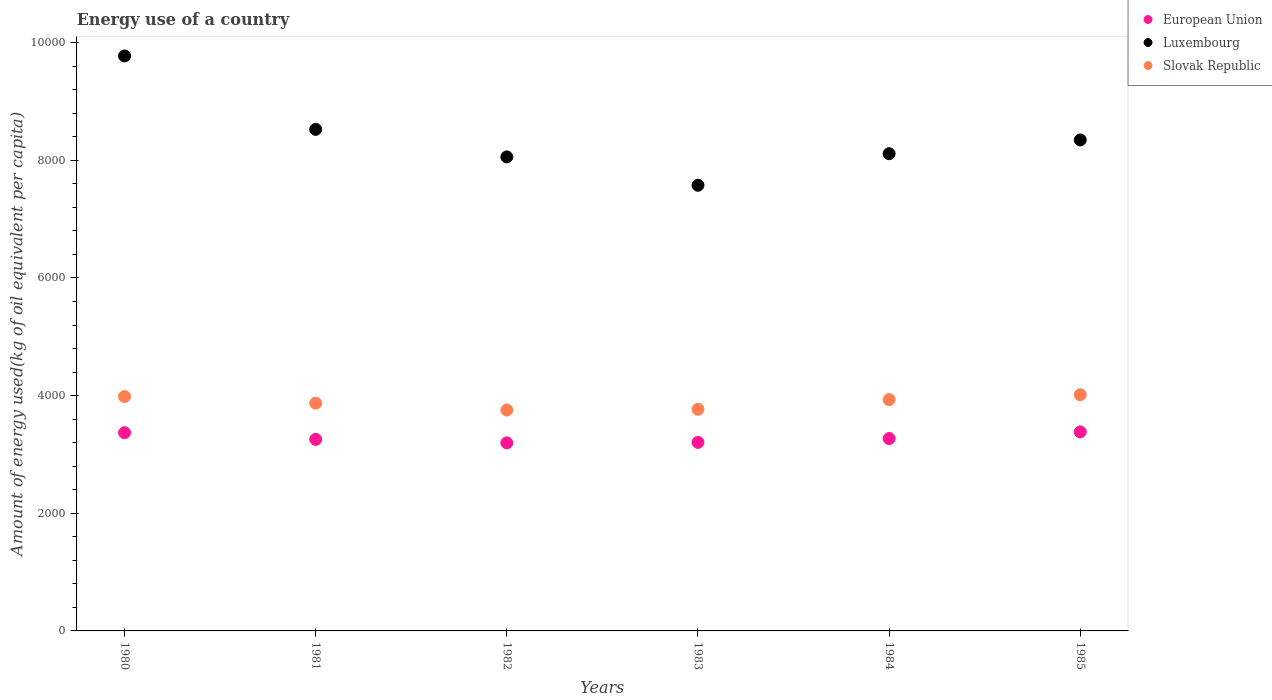How many different coloured dotlines are there?
Give a very brief answer. 3. What is the amount of energy used in in Luxembourg in 1982?
Provide a short and direct response. 8057.81. Across all years, what is the maximum amount of energy used in in European Union?
Your response must be concise. 3383.17. Across all years, what is the minimum amount of energy used in in European Union?
Your answer should be compact. 3196.65. In which year was the amount of energy used in in Luxembourg minimum?
Give a very brief answer. 1983. What is the total amount of energy used in in European Union in the graph?
Provide a succinct answer. 1.97e+04. What is the difference between the amount of energy used in in Luxembourg in 1981 and that in 1982?
Provide a succinct answer. 468.23. What is the difference between the amount of energy used in in European Union in 1980 and the amount of energy used in in Luxembourg in 1982?
Ensure brevity in your answer.  -4688.42. What is the average amount of energy used in in European Union per year?
Your answer should be very brief. 3280.22. In the year 1983, what is the difference between the amount of energy used in in Slovak Republic and amount of energy used in in European Union?
Make the answer very short. 562.69. In how many years, is the amount of energy used in in European Union greater than 8400 kg?
Your answer should be compact. 0. What is the ratio of the amount of energy used in in Slovak Republic in 1980 to that in 1982?
Keep it short and to the point. 1.06. Is the amount of energy used in in European Union in 1981 less than that in 1984?
Offer a terse response. Yes. Is the difference between the amount of energy used in in Slovak Republic in 1980 and 1981 greater than the difference between the amount of energy used in in European Union in 1980 and 1981?
Ensure brevity in your answer.  No. What is the difference between the highest and the second highest amount of energy used in in Slovak Republic?
Keep it short and to the point. 31.31. What is the difference between the highest and the lowest amount of energy used in in Luxembourg?
Ensure brevity in your answer.  2198.44. In how many years, is the amount of energy used in in Luxembourg greater than the average amount of energy used in in Luxembourg taken over all years?
Your answer should be compact. 2. Is the amount of energy used in in Luxembourg strictly less than the amount of energy used in in European Union over the years?
Give a very brief answer. No. How many dotlines are there?
Ensure brevity in your answer.  3. What is the difference between two consecutive major ticks on the Y-axis?
Ensure brevity in your answer.  2000. Does the graph contain any zero values?
Your response must be concise. No. Where does the legend appear in the graph?
Your answer should be compact. Top right. What is the title of the graph?
Provide a short and direct response. Energy use of a country. What is the label or title of the X-axis?
Offer a terse response. Years. What is the label or title of the Y-axis?
Your answer should be very brief. Amount of energy used(kg of oil equivalent per capita). What is the Amount of energy used(kg of oil equivalent per capita) of European Union in 1980?
Offer a terse response. 3369.39. What is the Amount of energy used(kg of oil equivalent per capita) in Luxembourg in 1980?
Keep it short and to the point. 9774.65. What is the Amount of energy used(kg of oil equivalent per capita) in Slovak Republic in 1980?
Provide a short and direct response. 3983.84. What is the Amount of energy used(kg of oil equivalent per capita) in European Union in 1981?
Your answer should be very brief. 3256.81. What is the Amount of energy used(kg of oil equivalent per capita) of Luxembourg in 1981?
Provide a succinct answer. 8526.04. What is the Amount of energy used(kg of oil equivalent per capita) of Slovak Republic in 1981?
Give a very brief answer. 3872.54. What is the Amount of energy used(kg of oil equivalent per capita) in European Union in 1982?
Offer a very short reply. 3196.65. What is the Amount of energy used(kg of oil equivalent per capita) in Luxembourg in 1982?
Your answer should be compact. 8057.81. What is the Amount of energy used(kg of oil equivalent per capita) of Slovak Republic in 1982?
Offer a very short reply. 3754.68. What is the Amount of energy used(kg of oil equivalent per capita) of European Union in 1983?
Ensure brevity in your answer.  3204.9. What is the Amount of energy used(kg of oil equivalent per capita) in Luxembourg in 1983?
Ensure brevity in your answer.  7576.21. What is the Amount of energy used(kg of oil equivalent per capita) of Slovak Republic in 1983?
Your response must be concise. 3767.6. What is the Amount of energy used(kg of oil equivalent per capita) in European Union in 1984?
Your answer should be very brief. 3270.42. What is the Amount of energy used(kg of oil equivalent per capita) in Luxembourg in 1984?
Give a very brief answer. 8112.68. What is the Amount of energy used(kg of oil equivalent per capita) of Slovak Republic in 1984?
Ensure brevity in your answer.  3932.19. What is the Amount of energy used(kg of oil equivalent per capita) of European Union in 1985?
Provide a short and direct response. 3383.17. What is the Amount of energy used(kg of oil equivalent per capita) in Luxembourg in 1985?
Give a very brief answer. 8346.93. What is the Amount of energy used(kg of oil equivalent per capita) in Slovak Republic in 1985?
Provide a succinct answer. 4015.15. Across all years, what is the maximum Amount of energy used(kg of oil equivalent per capita) of European Union?
Provide a succinct answer. 3383.17. Across all years, what is the maximum Amount of energy used(kg of oil equivalent per capita) in Luxembourg?
Ensure brevity in your answer.  9774.65. Across all years, what is the maximum Amount of energy used(kg of oil equivalent per capita) in Slovak Republic?
Offer a very short reply. 4015.15. Across all years, what is the minimum Amount of energy used(kg of oil equivalent per capita) of European Union?
Keep it short and to the point. 3196.65. Across all years, what is the minimum Amount of energy used(kg of oil equivalent per capita) of Luxembourg?
Provide a short and direct response. 7576.21. Across all years, what is the minimum Amount of energy used(kg of oil equivalent per capita) of Slovak Republic?
Offer a terse response. 3754.68. What is the total Amount of energy used(kg of oil equivalent per capita) of European Union in the graph?
Your answer should be compact. 1.97e+04. What is the total Amount of energy used(kg of oil equivalent per capita) of Luxembourg in the graph?
Your response must be concise. 5.04e+04. What is the total Amount of energy used(kg of oil equivalent per capita) in Slovak Republic in the graph?
Your answer should be very brief. 2.33e+04. What is the difference between the Amount of energy used(kg of oil equivalent per capita) of European Union in 1980 and that in 1981?
Keep it short and to the point. 112.58. What is the difference between the Amount of energy used(kg of oil equivalent per capita) in Luxembourg in 1980 and that in 1981?
Your answer should be compact. 1248.61. What is the difference between the Amount of energy used(kg of oil equivalent per capita) of Slovak Republic in 1980 and that in 1981?
Provide a short and direct response. 111.31. What is the difference between the Amount of energy used(kg of oil equivalent per capita) of European Union in 1980 and that in 1982?
Your answer should be compact. 172.74. What is the difference between the Amount of energy used(kg of oil equivalent per capita) of Luxembourg in 1980 and that in 1982?
Your answer should be very brief. 1716.84. What is the difference between the Amount of energy used(kg of oil equivalent per capita) of Slovak Republic in 1980 and that in 1982?
Make the answer very short. 229.16. What is the difference between the Amount of energy used(kg of oil equivalent per capita) of European Union in 1980 and that in 1983?
Give a very brief answer. 164.49. What is the difference between the Amount of energy used(kg of oil equivalent per capita) of Luxembourg in 1980 and that in 1983?
Offer a terse response. 2198.44. What is the difference between the Amount of energy used(kg of oil equivalent per capita) in Slovak Republic in 1980 and that in 1983?
Keep it short and to the point. 216.25. What is the difference between the Amount of energy used(kg of oil equivalent per capita) in European Union in 1980 and that in 1984?
Ensure brevity in your answer.  98.97. What is the difference between the Amount of energy used(kg of oil equivalent per capita) in Luxembourg in 1980 and that in 1984?
Offer a very short reply. 1661.98. What is the difference between the Amount of energy used(kg of oil equivalent per capita) in Slovak Republic in 1980 and that in 1984?
Make the answer very short. 51.65. What is the difference between the Amount of energy used(kg of oil equivalent per capita) of European Union in 1980 and that in 1985?
Make the answer very short. -13.78. What is the difference between the Amount of energy used(kg of oil equivalent per capita) in Luxembourg in 1980 and that in 1985?
Give a very brief answer. 1427.72. What is the difference between the Amount of energy used(kg of oil equivalent per capita) of Slovak Republic in 1980 and that in 1985?
Your answer should be very brief. -31.31. What is the difference between the Amount of energy used(kg of oil equivalent per capita) of European Union in 1981 and that in 1982?
Offer a very short reply. 60.16. What is the difference between the Amount of energy used(kg of oil equivalent per capita) of Luxembourg in 1981 and that in 1982?
Give a very brief answer. 468.23. What is the difference between the Amount of energy used(kg of oil equivalent per capita) in Slovak Republic in 1981 and that in 1982?
Your answer should be compact. 117.86. What is the difference between the Amount of energy used(kg of oil equivalent per capita) of European Union in 1981 and that in 1983?
Ensure brevity in your answer.  51.91. What is the difference between the Amount of energy used(kg of oil equivalent per capita) of Luxembourg in 1981 and that in 1983?
Your answer should be very brief. 949.83. What is the difference between the Amount of energy used(kg of oil equivalent per capita) of Slovak Republic in 1981 and that in 1983?
Ensure brevity in your answer.  104.94. What is the difference between the Amount of energy used(kg of oil equivalent per capita) of European Union in 1981 and that in 1984?
Keep it short and to the point. -13.61. What is the difference between the Amount of energy used(kg of oil equivalent per capita) of Luxembourg in 1981 and that in 1984?
Your response must be concise. 413.36. What is the difference between the Amount of energy used(kg of oil equivalent per capita) of Slovak Republic in 1981 and that in 1984?
Ensure brevity in your answer.  -59.66. What is the difference between the Amount of energy used(kg of oil equivalent per capita) in European Union in 1981 and that in 1985?
Your answer should be very brief. -126.36. What is the difference between the Amount of energy used(kg of oil equivalent per capita) in Luxembourg in 1981 and that in 1985?
Give a very brief answer. 179.11. What is the difference between the Amount of energy used(kg of oil equivalent per capita) in Slovak Republic in 1981 and that in 1985?
Make the answer very short. -142.62. What is the difference between the Amount of energy used(kg of oil equivalent per capita) of European Union in 1982 and that in 1983?
Your response must be concise. -8.25. What is the difference between the Amount of energy used(kg of oil equivalent per capita) in Luxembourg in 1982 and that in 1983?
Give a very brief answer. 481.6. What is the difference between the Amount of energy used(kg of oil equivalent per capita) in Slovak Republic in 1982 and that in 1983?
Your response must be concise. -12.92. What is the difference between the Amount of energy used(kg of oil equivalent per capita) in European Union in 1982 and that in 1984?
Keep it short and to the point. -73.77. What is the difference between the Amount of energy used(kg of oil equivalent per capita) in Luxembourg in 1982 and that in 1984?
Your answer should be compact. -54.87. What is the difference between the Amount of energy used(kg of oil equivalent per capita) in Slovak Republic in 1982 and that in 1984?
Your answer should be very brief. -177.51. What is the difference between the Amount of energy used(kg of oil equivalent per capita) of European Union in 1982 and that in 1985?
Provide a short and direct response. -186.52. What is the difference between the Amount of energy used(kg of oil equivalent per capita) in Luxembourg in 1982 and that in 1985?
Offer a terse response. -289.12. What is the difference between the Amount of energy used(kg of oil equivalent per capita) of Slovak Republic in 1982 and that in 1985?
Keep it short and to the point. -260.47. What is the difference between the Amount of energy used(kg of oil equivalent per capita) of European Union in 1983 and that in 1984?
Offer a very short reply. -65.52. What is the difference between the Amount of energy used(kg of oil equivalent per capita) in Luxembourg in 1983 and that in 1984?
Give a very brief answer. -536.47. What is the difference between the Amount of energy used(kg of oil equivalent per capita) of Slovak Republic in 1983 and that in 1984?
Provide a succinct answer. -164.6. What is the difference between the Amount of energy used(kg of oil equivalent per capita) of European Union in 1983 and that in 1985?
Your response must be concise. -178.27. What is the difference between the Amount of energy used(kg of oil equivalent per capita) in Luxembourg in 1983 and that in 1985?
Your response must be concise. -770.72. What is the difference between the Amount of energy used(kg of oil equivalent per capita) of Slovak Republic in 1983 and that in 1985?
Offer a very short reply. -247.56. What is the difference between the Amount of energy used(kg of oil equivalent per capita) in European Union in 1984 and that in 1985?
Your response must be concise. -112.75. What is the difference between the Amount of energy used(kg of oil equivalent per capita) in Luxembourg in 1984 and that in 1985?
Offer a terse response. -234.25. What is the difference between the Amount of energy used(kg of oil equivalent per capita) of Slovak Republic in 1984 and that in 1985?
Offer a terse response. -82.96. What is the difference between the Amount of energy used(kg of oil equivalent per capita) in European Union in 1980 and the Amount of energy used(kg of oil equivalent per capita) in Luxembourg in 1981?
Provide a short and direct response. -5156.65. What is the difference between the Amount of energy used(kg of oil equivalent per capita) of European Union in 1980 and the Amount of energy used(kg of oil equivalent per capita) of Slovak Republic in 1981?
Make the answer very short. -503.15. What is the difference between the Amount of energy used(kg of oil equivalent per capita) of Luxembourg in 1980 and the Amount of energy used(kg of oil equivalent per capita) of Slovak Republic in 1981?
Provide a short and direct response. 5902.11. What is the difference between the Amount of energy used(kg of oil equivalent per capita) in European Union in 1980 and the Amount of energy used(kg of oil equivalent per capita) in Luxembourg in 1982?
Offer a very short reply. -4688.42. What is the difference between the Amount of energy used(kg of oil equivalent per capita) of European Union in 1980 and the Amount of energy used(kg of oil equivalent per capita) of Slovak Republic in 1982?
Make the answer very short. -385.29. What is the difference between the Amount of energy used(kg of oil equivalent per capita) in Luxembourg in 1980 and the Amount of energy used(kg of oil equivalent per capita) in Slovak Republic in 1982?
Ensure brevity in your answer.  6019.97. What is the difference between the Amount of energy used(kg of oil equivalent per capita) in European Union in 1980 and the Amount of energy used(kg of oil equivalent per capita) in Luxembourg in 1983?
Provide a succinct answer. -4206.82. What is the difference between the Amount of energy used(kg of oil equivalent per capita) in European Union in 1980 and the Amount of energy used(kg of oil equivalent per capita) in Slovak Republic in 1983?
Ensure brevity in your answer.  -398.21. What is the difference between the Amount of energy used(kg of oil equivalent per capita) of Luxembourg in 1980 and the Amount of energy used(kg of oil equivalent per capita) of Slovak Republic in 1983?
Ensure brevity in your answer.  6007.05. What is the difference between the Amount of energy used(kg of oil equivalent per capita) of European Union in 1980 and the Amount of energy used(kg of oil equivalent per capita) of Luxembourg in 1984?
Keep it short and to the point. -4743.29. What is the difference between the Amount of energy used(kg of oil equivalent per capita) in European Union in 1980 and the Amount of energy used(kg of oil equivalent per capita) in Slovak Republic in 1984?
Provide a short and direct response. -562.8. What is the difference between the Amount of energy used(kg of oil equivalent per capita) in Luxembourg in 1980 and the Amount of energy used(kg of oil equivalent per capita) in Slovak Republic in 1984?
Offer a terse response. 5842.46. What is the difference between the Amount of energy used(kg of oil equivalent per capita) of European Union in 1980 and the Amount of energy used(kg of oil equivalent per capita) of Luxembourg in 1985?
Your answer should be compact. -4977.54. What is the difference between the Amount of energy used(kg of oil equivalent per capita) of European Union in 1980 and the Amount of energy used(kg of oil equivalent per capita) of Slovak Republic in 1985?
Offer a terse response. -645.76. What is the difference between the Amount of energy used(kg of oil equivalent per capita) in Luxembourg in 1980 and the Amount of energy used(kg of oil equivalent per capita) in Slovak Republic in 1985?
Make the answer very short. 5759.5. What is the difference between the Amount of energy used(kg of oil equivalent per capita) in European Union in 1981 and the Amount of energy used(kg of oil equivalent per capita) in Luxembourg in 1982?
Your answer should be very brief. -4801. What is the difference between the Amount of energy used(kg of oil equivalent per capita) of European Union in 1981 and the Amount of energy used(kg of oil equivalent per capita) of Slovak Republic in 1982?
Provide a succinct answer. -497.87. What is the difference between the Amount of energy used(kg of oil equivalent per capita) in Luxembourg in 1981 and the Amount of energy used(kg of oil equivalent per capita) in Slovak Republic in 1982?
Make the answer very short. 4771.36. What is the difference between the Amount of energy used(kg of oil equivalent per capita) of European Union in 1981 and the Amount of energy used(kg of oil equivalent per capita) of Luxembourg in 1983?
Offer a very short reply. -4319.4. What is the difference between the Amount of energy used(kg of oil equivalent per capita) of European Union in 1981 and the Amount of energy used(kg of oil equivalent per capita) of Slovak Republic in 1983?
Your answer should be compact. -510.79. What is the difference between the Amount of energy used(kg of oil equivalent per capita) in Luxembourg in 1981 and the Amount of energy used(kg of oil equivalent per capita) in Slovak Republic in 1983?
Provide a short and direct response. 4758.44. What is the difference between the Amount of energy used(kg of oil equivalent per capita) of European Union in 1981 and the Amount of energy used(kg of oil equivalent per capita) of Luxembourg in 1984?
Offer a very short reply. -4855.87. What is the difference between the Amount of energy used(kg of oil equivalent per capita) of European Union in 1981 and the Amount of energy used(kg of oil equivalent per capita) of Slovak Republic in 1984?
Ensure brevity in your answer.  -675.38. What is the difference between the Amount of energy used(kg of oil equivalent per capita) of Luxembourg in 1981 and the Amount of energy used(kg of oil equivalent per capita) of Slovak Republic in 1984?
Offer a terse response. 4593.84. What is the difference between the Amount of energy used(kg of oil equivalent per capita) of European Union in 1981 and the Amount of energy used(kg of oil equivalent per capita) of Luxembourg in 1985?
Your response must be concise. -5090.12. What is the difference between the Amount of energy used(kg of oil equivalent per capita) in European Union in 1981 and the Amount of energy used(kg of oil equivalent per capita) in Slovak Republic in 1985?
Keep it short and to the point. -758.34. What is the difference between the Amount of energy used(kg of oil equivalent per capita) in Luxembourg in 1981 and the Amount of energy used(kg of oil equivalent per capita) in Slovak Republic in 1985?
Make the answer very short. 4510.89. What is the difference between the Amount of energy used(kg of oil equivalent per capita) in European Union in 1982 and the Amount of energy used(kg of oil equivalent per capita) in Luxembourg in 1983?
Provide a succinct answer. -4379.56. What is the difference between the Amount of energy used(kg of oil equivalent per capita) in European Union in 1982 and the Amount of energy used(kg of oil equivalent per capita) in Slovak Republic in 1983?
Offer a terse response. -570.95. What is the difference between the Amount of energy used(kg of oil equivalent per capita) of Luxembourg in 1982 and the Amount of energy used(kg of oil equivalent per capita) of Slovak Republic in 1983?
Keep it short and to the point. 4290.21. What is the difference between the Amount of energy used(kg of oil equivalent per capita) of European Union in 1982 and the Amount of energy used(kg of oil equivalent per capita) of Luxembourg in 1984?
Your answer should be compact. -4916.02. What is the difference between the Amount of energy used(kg of oil equivalent per capita) of European Union in 1982 and the Amount of energy used(kg of oil equivalent per capita) of Slovak Republic in 1984?
Offer a very short reply. -735.54. What is the difference between the Amount of energy used(kg of oil equivalent per capita) in Luxembourg in 1982 and the Amount of energy used(kg of oil equivalent per capita) in Slovak Republic in 1984?
Provide a short and direct response. 4125.62. What is the difference between the Amount of energy used(kg of oil equivalent per capita) in European Union in 1982 and the Amount of energy used(kg of oil equivalent per capita) in Luxembourg in 1985?
Provide a succinct answer. -5150.28. What is the difference between the Amount of energy used(kg of oil equivalent per capita) in European Union in 1982 and the Amount of energy used(kg of oil equivalent per capita) in Slovak Republic in 1985?
Offer a very short reply. -818.5. What is the difference between the Amount of energy used(kg of oil equivalent per capita) of Luxembourg in 1982 and the Amount of energy used(kg of oil equivalent per capita) of Slovak Republic in 1985?
Keep it short and to the point. 4042.66. What is the difference between the Amount of energy used(kg of oil equivalent per capita) of European Union in 1983 and the Amount of energy used(kg of oil equivalent per capita) of Luxembourg in 1984?
Your answer should be compact. -4907.77. What is the difference between the Amount of energy used(kg of oil equivalent per capita) in European Union in 1983 and the Amount of energy used(kg of oil equivalent per capita) in Slovak Republic in 1984?
Your answer should be compact. -727.29. What is the difference between the Amount of energy used(kg of oil equivalent per capita) of Luxembourg in 1983 and the Amount of energy used(kg of oil equivalent per capita) of Slovak Republic in 1984?
Provide a short and direct response. 3644.01. What is the difference between the Amount of energy used(kg of oil equivalent per capita) of European Union in 1983 and the Amount of energy used(kg of oil equivalent per capita) of Luxembourg in 1985?
Your response must be concise. -5142.02. What is the difference between the Amount of energy used(kg of oil equivalent per capita) in European Union in 1983 and the Amount of energy used(kg of oil equivalent per capita) in Slovak Republic in 1985?
Make the answer very short. -810.25. What is the difference between the Amount of energy used(kg of oil equivalent per capita) in Luxembourg in 1983 and the Amount of energy used(kg of oil equivalent per capita) in Slovak Republic in 1985?
Keep it short and to the point. 3561.05. What is the difference between the Amount of energy used(kg of oil equivalent per capita) of European Union in 1984 and the Amount of energy used(kg of oil equivalent per capita) of Luxembourg in 1985?
Keep it short and to the point. -5076.51. What is the difference between the Amount of energy used(kg of oil equivalent per capita) of European Union in 1984 and the Amount of energy used(kg of oil equivalent per capita) of Slovak Republic in 1985?
Make the answer very short. -744.73. What is the difference between the Amount of energy used(kg of oil equivalent per capita) of Luxembourg in 1984 and the Amount of energy used(kg of oil equivalent per capita) of Slovak Republic in 1985?
Your answer should be compact. 4097.52. What is the average Amount of energy used(kg of oil equivalent per capita) in European Union per year?
Offer a terse response. 3280.22. What is the average Amount of energy used(kg of oil equivalent per capita) of Luxembourg per year?
Provide a short and direct response. 8399.05. What is the average Amount of energy used(kg of oil equivalent per capita) in Slovak Republic per year?
Ensure brevity in your answer.  3887.67. In the year 1980, what is the difference between the Amount of energy used(kg of oil equivalent per capita) of European Union and Amount of energy used(kg of oil equivalent per capita) of Luxembourg?
Give a very brief answer. -6405.26. In the year 1980, what is the difference between the Amount of energy used(kg of oil equivalent per capita) in European Union and Amount of energy used(kg of oil equivalent per capita) in Slovak Republic?
Offer a terse response. -614.45. In the year 1980, what is the difference between the Amount of energy used(kg of oil equivalent per capita) of Luxembourg and Amount of energy used(kg of oil equivalent per capita) of Slovak Republic?
Provide a succinct answer. 5790.81. In the year 1981, what is the difference between the Amount of energy used(kg of oil equivalent per capita) in European Union and Amount of energy used(kg of oil equivalent per capita) in Luxembourg?
Offer a terse response. -5269.23. In the year 1981, what is the difference between the Amount of energy used(kg of oil equivalent per capita) in European Union and Amount of energy used(kg of oil equivalent per capita) in Slovak Republic?
Your response must be concise. -615.73. In the year 1981, what is the difference between the Amount of energy used(kg of oil equivalent per capita) in Luxembourg and Amount of energy used(kg of oil equivalent per capita) in Slovak Republic?
Your response must be concise. 4653.5. In the year 1982, what is the difference between the Amount of energy used(kg of oil equivalent per capita) in European Union and Amount of energy used(kg of oil equivalent per capita) in Luxembourg?
Provide a short and direct response. -4861.16. In the year 1982, what is the difference between the Amount of energy used(kg of oil equivalent per capita) in European Union and Amount of energy used(kg of oil equivalent per capita) in Slovak Republic?
Give a very brief answer. -558.03. In the year 1982, what is the difference between the Amount of energy used(kg of oil equivalent per capita) of Luxembourg and Amount of energy used(kg of oil equivalent per capita) of Slovak Republic?
Offer a terse response. 4303.13. In the year 1983, what is the difference between the Amount of energy used(kg of oil equivalent per capita) in European Union and Amount of energy used(kg of oil equivalent per capita) in Luxembourg?
Offer a very short reply. -4371.3. In the year 1983, what is the difference between the Amount of energy used(kg of oil equivalent per capita) in European Union and Amount of energy used(kg of oil equivalent per capita) in Slovak Republic?
Keep it short and to the point. -562.69. In the year 1983, what is the difference between the Amount of energy used(kg of oil equivalent per capita) of Luxembourg and Amount of energy used(kg of oil equivalent per capita) of Slovak Republic?
Keep it short and to the point. 3808.61. In the year 1984, what is the difference between the Amount of energy used(kg of oil equivalent per capita) in European Union and Amount of energy used(kg of oil equivalent per capita) in Luxembourg?
Your response must be concise. -4842.25. In the year 1984, what is the difference between the Amount of energy used(kg of oil equivalent per capita) of European Union and Amount of energy used(kg of oil equivalent per capita) of Slovak Republic?
Offer a very short reply. -661.77. In the year 1984, what is the difference between the Amount of energy used(kg of oil equivalent per capita) of Luxembourg and Amount of energy used(kg of oil equivalent per capita) of Slovak Republic?
Provide a succinct answer. 4180.48. In the year 1985, what is the difference between the Amount of energy used(kg of oil equivalent per capita) in European Union and Amount of energy used(kg of oil equivalent per capita) in Luxembourg?
Ensure brevity in your answer.  -4963.76. In the year 1985, what is the difference between the Amount of energy used(kg of oil equivalent per capita) in European Union and Amount of energy used(kg of oil equivalent per capita) in Slovak Republic?
Offer a terse response. -631.98. In the year 1985, what is the difference between the Amount of energy used(kg of oil equivalent per capita) of Luxembourg and Amount of energy used(kg of oil equivalent per capita) of Slovak Republic?
Make the answer very short. 4331.77. What is the ratio of the Amount of energy used(kg of oil equivalent per capita) of European Union in 1980 to that in 1981?
Provide a short and direct response. 1.03. What is the ratio of the Amount of energy used(kg of oil equivalent per capita) in Luxembourg in 1980 to that in 1981?
Your answer should be very brief. 1.15. What is the ratio of the Amount of energy used(kg of oil equivalent per capita) of Slovak Republic in 1980 to that in 1981?
Ensure brevity in your answer.  1.03. What is the ratio of the Amount of energy used(kg of oil equivalent per capita) in European Union in 1980 to that in 1982?
Offer a terse response. 1.05. What is the ratio of the Amount of energy used(kg of oil equivalent per capita) in Luxembourg in 1980 to that in 1982?
Keep it short and to the point. 1.21. What is the ratio of the Amount of energy used(kg of oil equivalent per capita) of Slovak Republic in 1980 to that in 1982?
Ensure brevity in your answer.  1.06. What is the ratio of the Amount of energy used(kg of oil equivalent per capita) of European Union in 1980 to that in 1983?
Make the answer very short. 1.05. What is the ratio of the Amount of energy used(kg of oil equivalent per capita) of Luxembourg in 1980 to that in 1983?
Provide a succinct answer. 1.29. What is the ratio of the Amount of energy used(kg of oil equivalent per capita) of Slovak Republic in 1980 to that in 1983?
Provide a short and direct response. 1.06. What is the ratio of the Amount of energy used(kg of oil equivalent per capita) in European Union in 1980 to that in 1984?
Your answer should be very brief. 1.03. What is the ratio of the Amount of energy used(kg of oil equivalent per capita) in Luxembourg in 1980 to that in 1984?
Your answer should be compact. 1.2. What is the ratio of the Amount of energy used(kg of oil equivalent per capita) of Slovak Republic in 1980 to that in 1984?
Offer a very short reply. 1.01. What is the ratio of the Amount of energy used(kg of oil equivalent per capita) in Luxembourg in 1980 to that in 1985?
Ensure brevity in your answer.  1.17. What is the ratio of the Amount of energy used(kg of oil equivalent per capita) of Slovak Republic in 1980 to that in 1985?
Provide a succinct answer. 0.99. What is the ratio of the Amount of energy used(kg of oil equivalent per capita) of European Union in 1981 to that in 1982?
Your answer should be compact. 1.02. What is the ratio of the Amount of energy used(kg of oil equivalent per capita) in Luxembourg in 1981 to that in 1982?
Offer a very short reply. 1.06. What is the ratio of the Amount of energy used(kg of oil equivalent per capita) in Slovak Republic in 1981 to that in 1982?
Offer a terse response. 1.03. What is the ratio of the Amount of energy used(kg of oil equivalent per capita) in European Union in 1981 to that in 1983?
Offer a very short reply. 1.02. What is the ratio of the Amount of energy used(kg of oil equivalent per capita) of Luxembourg in 1981 to that in 1983?
Provide a short and direct response. 1.13. What is the ratio of the Amount of energy used(kg of oil equivalent per capita) of Slovak Republic in 1981 to that in 1983?
Offer a very short reply. 1.03. What is the ratio of the Amount of energy used(kg of oil equivalent per capita) in European Union in 1981 to that in 1984?
Provide a succinct answer. 1. What is the ratio of the Amount of energy used(kg of oil equivalent per capita) in Luxembourg in 1981 to that in 1984?
Offer a terse response. 1.05. What is the ratio of the Amount of energy used(kg of oil equivalent per capita) of Slovak Republic in 1981 to that in 1984?
Ensure brevity in your answer.  0.98. What is the ratio of the Amount of energy used(kg of oil equivalent per capita) of European Union in 1981 to that in 1985?
Your answer should be very brief. 0.96. What is the ratio of the Amount of energy used(kg of oil equivalent per capita) in Luxembourg in 1981 to that in 1985?
Ensure brevity in your answer.  1.02. What is the ratio of the Amount of energy used(kg of oil equivalent per capita) in Slovak Republic in 1981 to that in 1985?
Your answer should be compact. 0.96. What is the ratio of the Amount of energy used(kg of oil equivalent per capita) in Luxembourg in 1982 to that in 1983?
Provide a short and direct response. 1.06. What is the ratio of the Amount of energy used(kg of oil equivalent per capita) in European Union in 1982 to that in 1984?
Your response must be concise. 0.98. What is the ratio of the Amount of energy used(kg of oil equivalent per capita) in Slovak Republic in 1982 to that in 1984?
Provide a short and direct response. 0.95. What is the ratio of the Amount of energy used(kg of oil equivalent per capita) in European Union in 1982 to that in 1985?
Offer a very short reply. 0.94. What is the ratio of the Amount of energy used(kg of oil equivalent per capita) of Luxembourg in 1982 to that in 1985?
Your answer should be compact. 0.97. What is the ratio of the Amount of energy used(kg of oil equivalent per capita) of Slovak Republic in 1982 to that in 1985?
Your answer should be compact. 0.94. What is the ratio of the Amount of energy used(kg of oil equivalent per capita) of European Union in 1983 to that in 1984?
Offer a very short reply. 0.98. What is the ratio of the Amount of energy used(kg of oil equivalent per capita) of Luxembourg in 1983 to that in 1984?
Make the answer very short. 0.93. What is the ratio of the Amount of energy used(kg of oil equivalent per capita) of Slovak Republic in 1983 to that in 1984?
Provide a short and direct response. 0.96. What is the ratio of the Amount of energy used(kg of oil equivalent per capita) in European Union in 1983 to that in 1985?
Keep it short and to the point. 0.95. What is the ratio of the Amount of energy used(kg of oil equivalent per capita) in Luxembourg in 1983 to that in 1985?
Your answer should be very brief. 0.91. What is the ratio of the Amount of energy used(kg of oil equivalent per capita) of Slovak Republic in 1983 to that in 1985?
Offer a very short reply. 0.94. What is the ratio of the Amount of energy used(kg of oil equivalent per capita) of European Union in 1984 to that in 1985?
Provide a short and direct response. 0.97. What is the ratio of the Amount of energy used(kg of oil equivalent per capita) in Luxembourg in 1984 to that in 1985?
Provide a succinct answer. 0.97. What is the ratio of the Amount of energy used(kg of oil equivalent per capita) of Slovak Republic in 1984 to that in 1985?
Ensure brevity in your answer.  0.98. What is the difference between the highest and the second highest Amount of energy used(kg of oil equivalent per capita) of European Union?
Offer a very short reply. 13.78. What is the difference between the highest and the second highest Amount of energy used(kg of oil equivalent per capita) of Luxembourg?
Give a very brief answer. 1248.61. What is the difference between the highest and the second highest Amount of energy used(kg of oil equivalent per capita) of Slovak Republic?
Offer a very short reply. 31.31. What is the difference between the highest and the lowest Amount of energy used(kg of oil equivalent per capita) in European Union?
Your answer should be very brief. 186.52. What is the difference between the highest and the lowest Amount of energy used(kg of oil equivalent per capita) in Luxembourg?
Your response must be concise. 2198.44. What is the difference between the highest and the lowest Amount of energy used(kg of oil equivalent per capita) in Slovak Republic?
Provide a succinct answer. 260.47. 